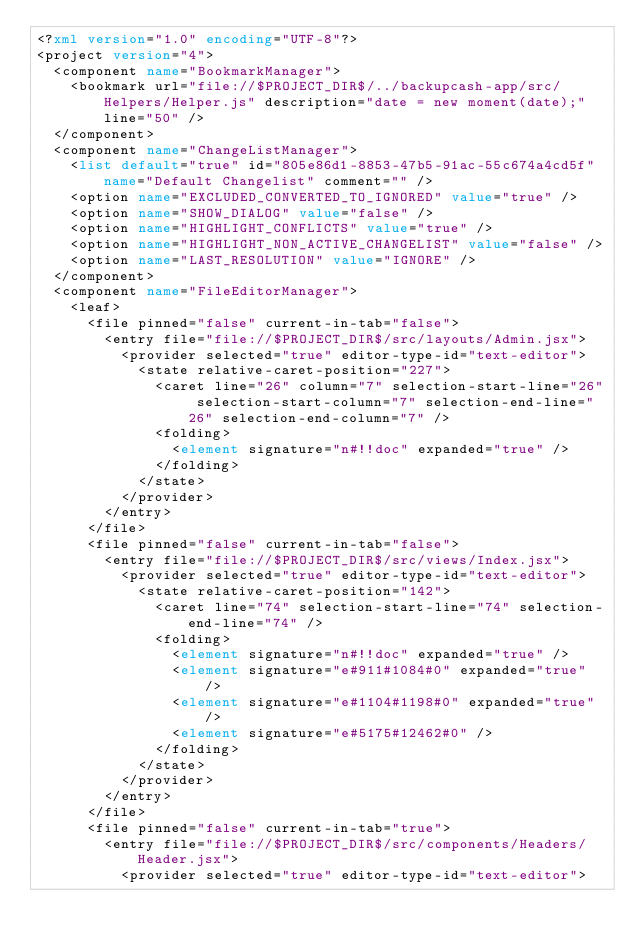<code> <loc_0><loc_0><loc_500><loc_500><_XML_><?xml version="1.0" encoding="UTF-8"?>
<project version="4">
  <component name="BookmarkManager">
    <bookmark url="file://$PROJECT_DIR$/../backupcash-app/src/Helpers/Helper.js" description="date = new moment(date);" line="50" />
  </component>
  <component name="ChangeListManager">
    <list default="true" id="805e86d1-8853-47b5-91ac-55c674a4cd5f" name="Default Changelist" comment="" />
    <option name="EXCLUDED_CONVERTED_TO_IGNORED" value="true" />
    <option name="SHOW_DIALOG" value="false" />
    <option name="HIGHLIGHT_CONFLICTS" value="true" />
    <option name="HIGHLIGHT_NON_ACTIVE_CHANGELIST" value="false" />
    <option name="LAST_RESOLUTION" value="IGNORE" />
  </component>
  <component name="FileEditorManager">
    <leaf>
      <file pinned="false" current-in-tab="false">
        <entry file="file://$PROJECT_DIR$/src/layouts/Admin.jsx">
          <provider selected="true" editor-type-id="text-editor">
            <state relative-caret-position="227">
              <caret line="26" column="7" selection-start-line="26" selection-start-column="7" selection-end-line="26" selection-end-column="7" />
              <folding>
                <element signature="n#!!doc" expanded="true" />
              </folding>
            </state>
          </provider>
        </entry>
      </file>
      <file pinned="false" current-in-tab="false">
        <entry file="file://$PROJECT_DIR$/src/views/Index.jsx">
          <provider selected="true" editor-type-id="text-editor">
            <state relative-caret-position="142">
              <caret line="74" selection-start-line="74" selection-end-line="74" />
              <folding>
                <element signature="n#!!doc" expanded="true" />
                <element signature="e#911#1084#0" expanded="true" />
                <element signature="e#1104#1198#0" expanded="true" />
                <element signature="e#5175#12462#0" />
              </folding>
            </state>
          </provider>
        </entry>
      </file>
      <file pinned="false" current-in-tab="true">
        <entry file="file://$PROJECT_DIR$/src/components/Headers/Header.jsx">
          <provider selected="true" editor-type-id="text-editor"></code> 